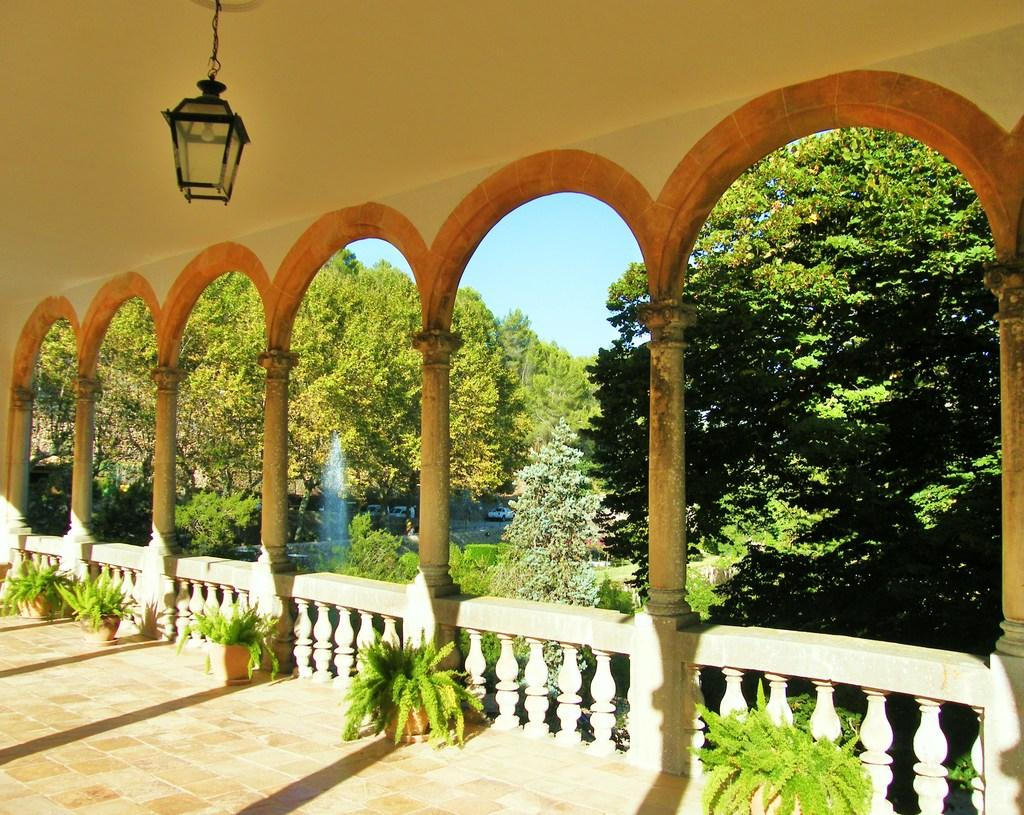What type of architectural feature can be seen on the right side of the image? There are pillars on the right side of the image. What is located near the pillars? There is a flower pot in the image. What type of vegetation is present in the image? There are plants and trees in the image. What else can be seen in the image? There are vehicles in the image. What is visible at the top right of the image? The sky is visible at the top right of the image. What can be seen at the top left of the image? There is a light visible at the top left of the image. What flavor of ice cream is being served at the gate in the image? There is no ice cream or gate present in the image. What type of border surrounds the image? The image does not have a border; it is a rectangular representation of the scene. 